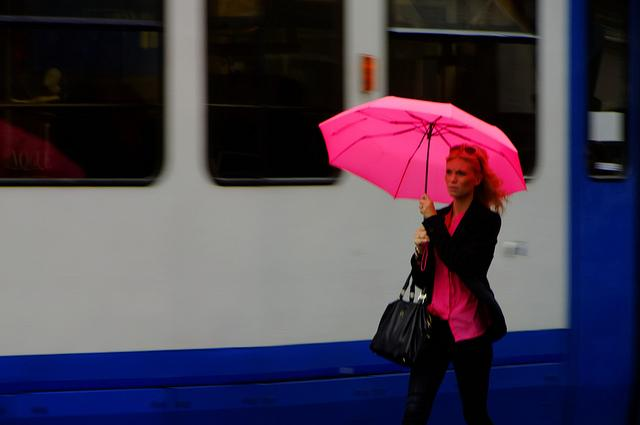Why does the woman use pink umbrella?

Choices:
A) camouflage
B) sunproof
C) match clothes
D) visibility match clothes 